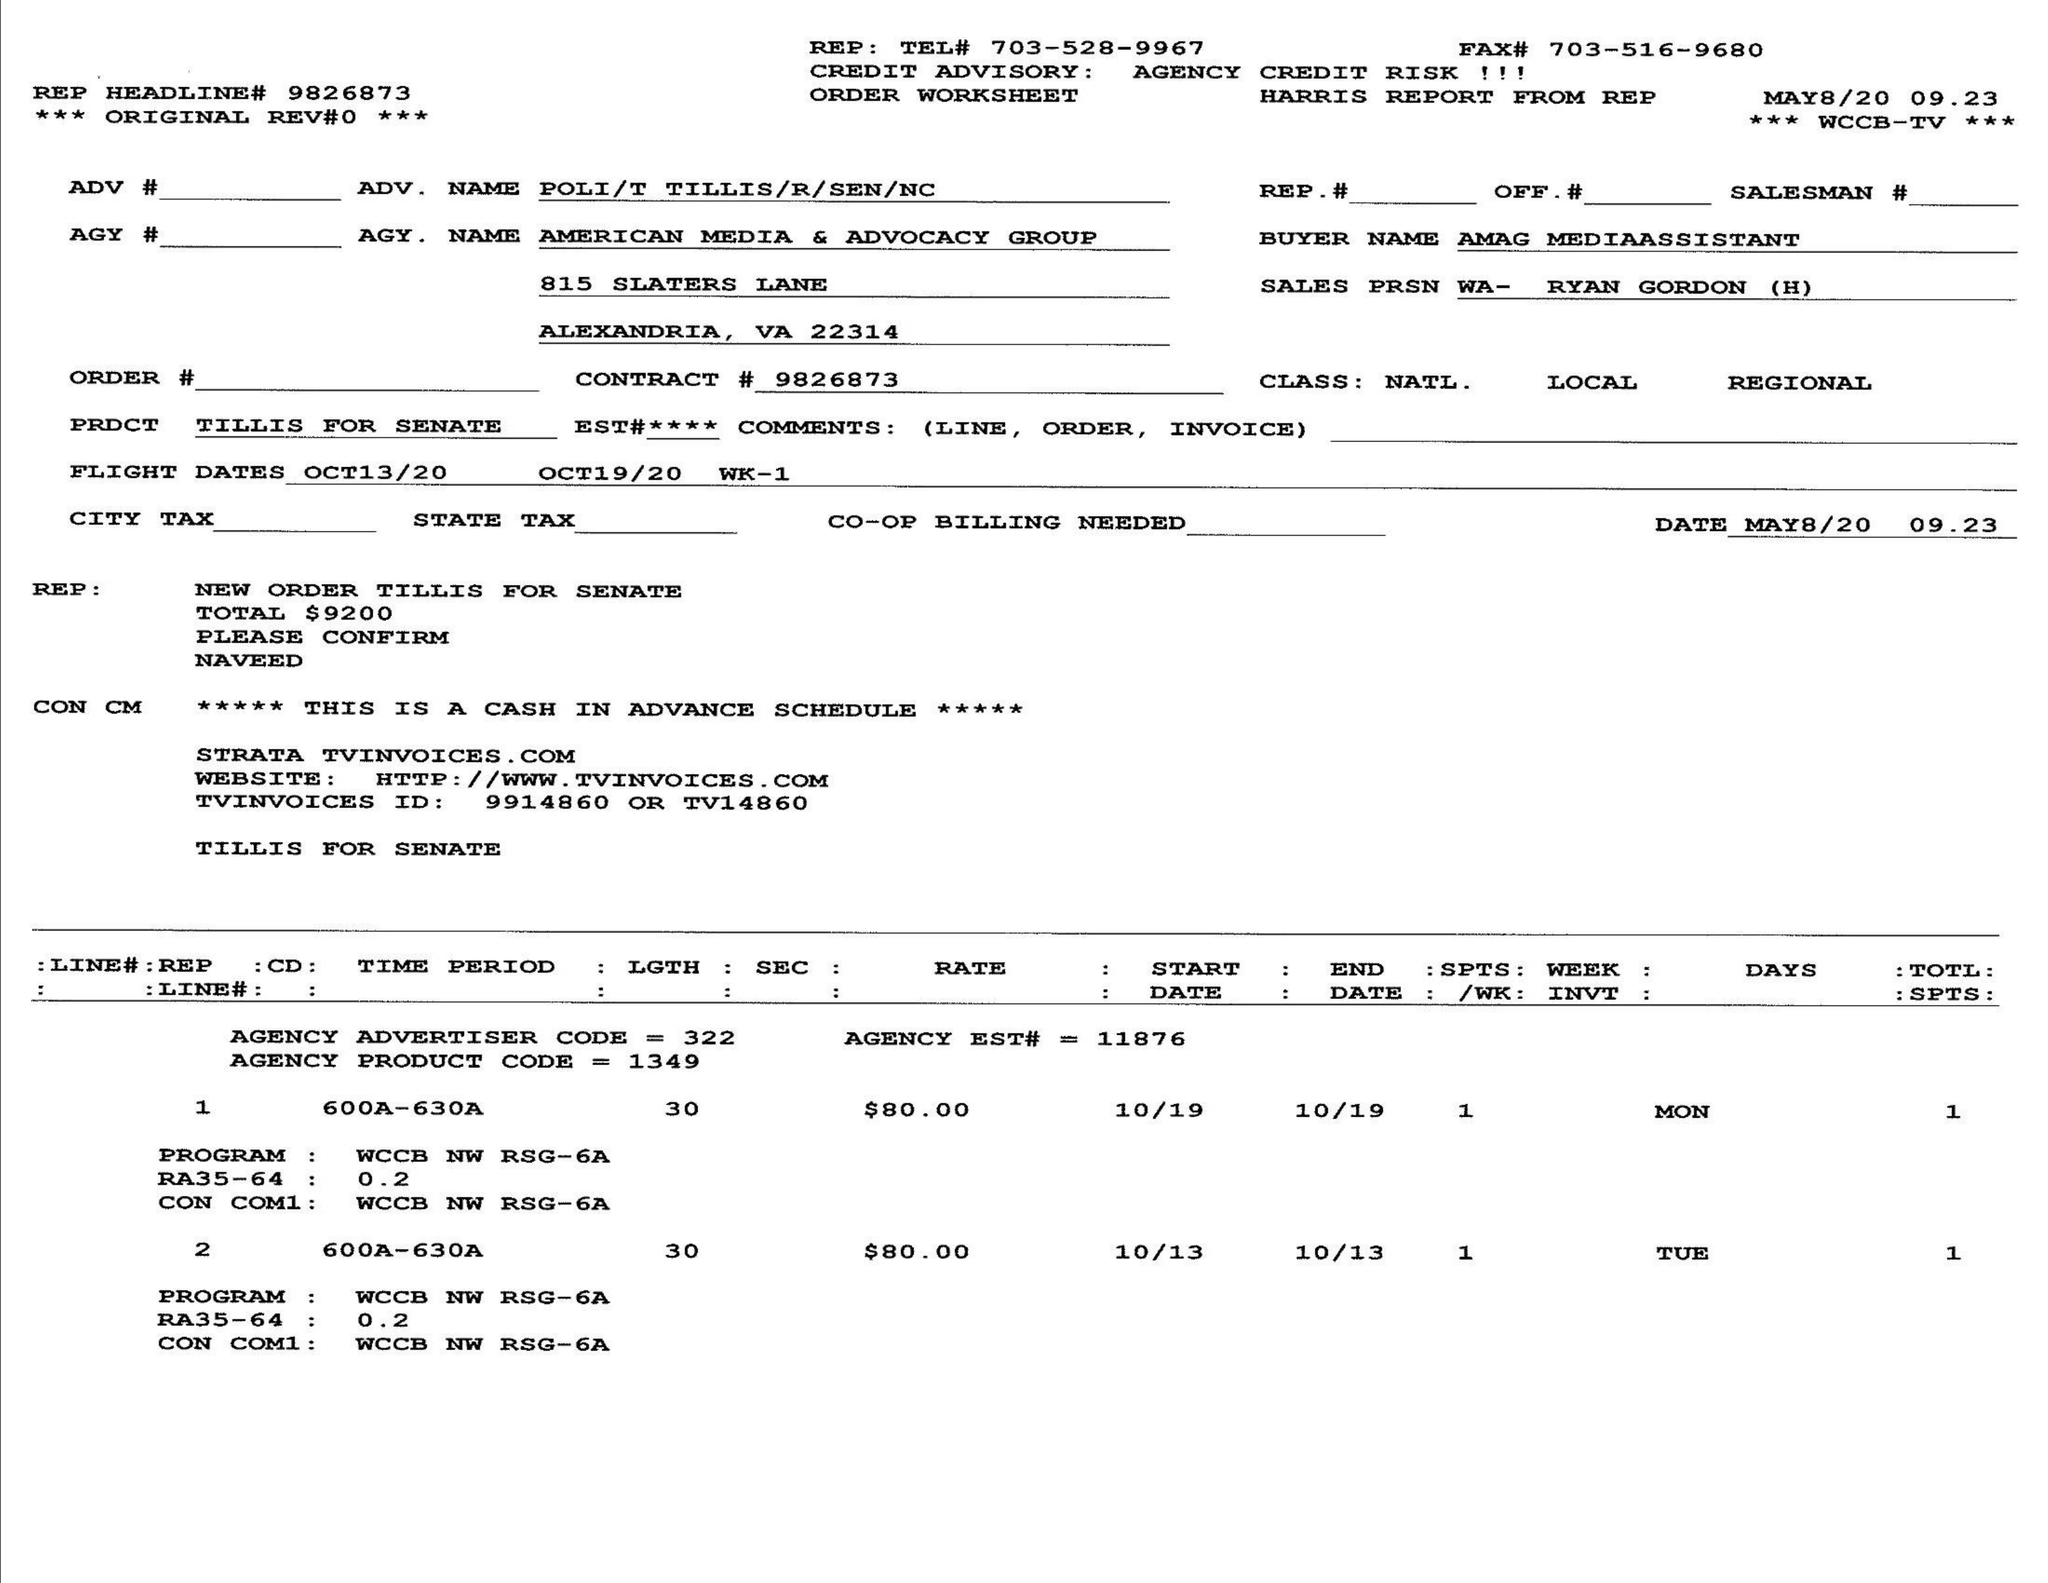What is the value for the contract_num?
Answer the question using a single word or phrase. 9826873 